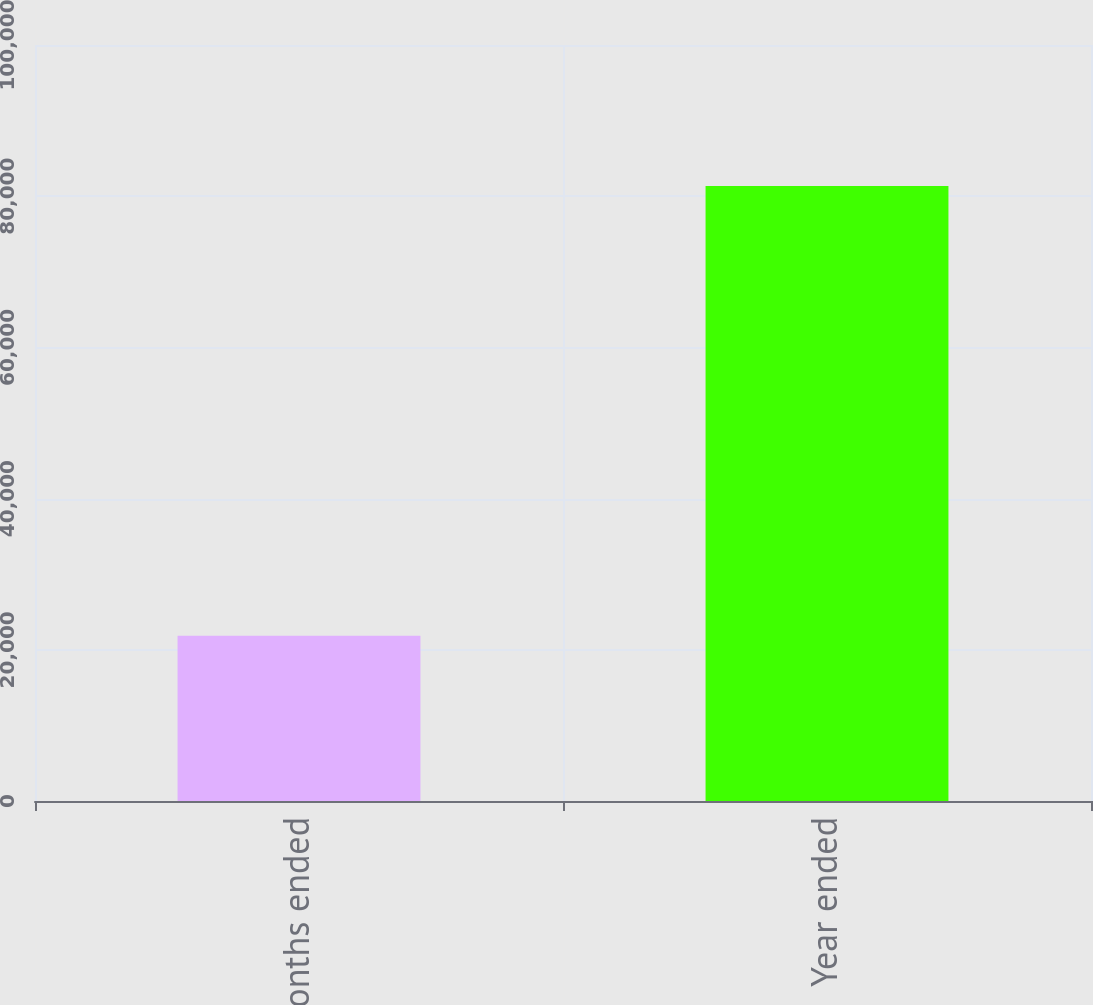Convert chart. <chart><loc_0><loc_0><loc_500><loc_500><bar_chart><fcel>Three months ended<fcel>Year ended<nl><fcel>21855<fcel>81356<nl></chart> 